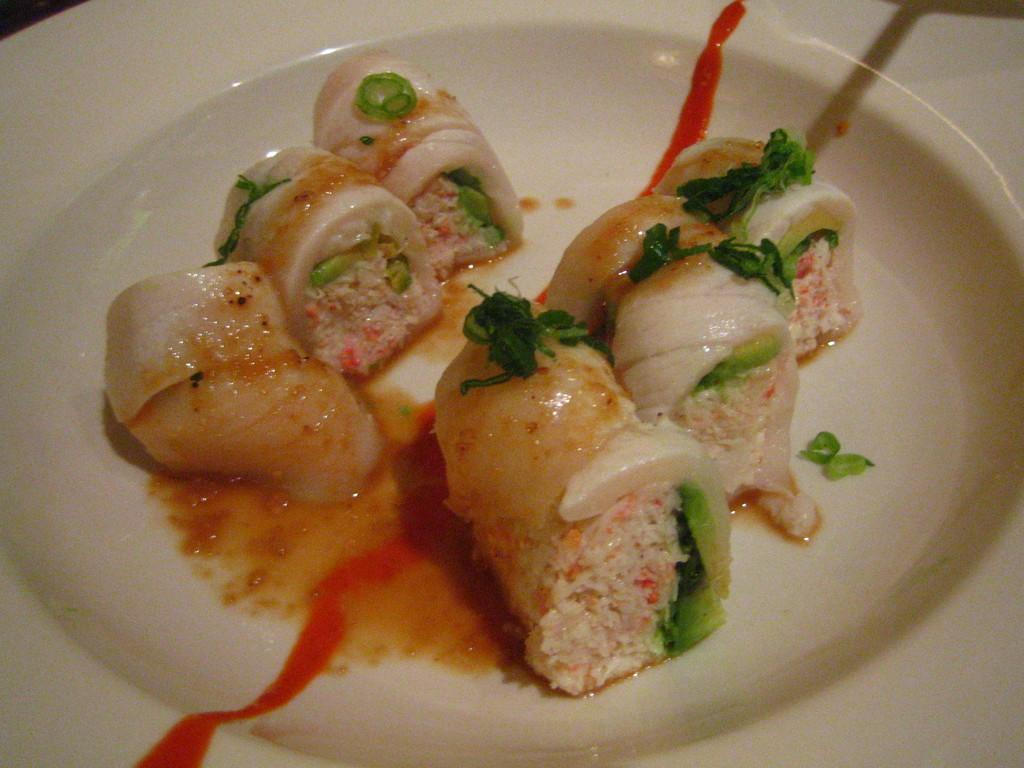What is on the plate that is visible in the image? There is food on a plate in the image. What type of garnish can be seen on the food in the image? Mint leaves are present on the food in the image. What type of pen is the secretary using to work on the document in the image? There is no secretary, document, or pen present in the image; it only features food with mint leaves on a plate. 